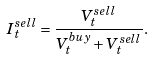<formula> <loc_0><loc_0><loc_500><loc_500>I _ { t } ^ { s e l l } = \frac { V _ { t } ^ { s e l l } } { V _ { t } ^ { b u y } + V _ { t } ^ { s e l l } } .</formula> 